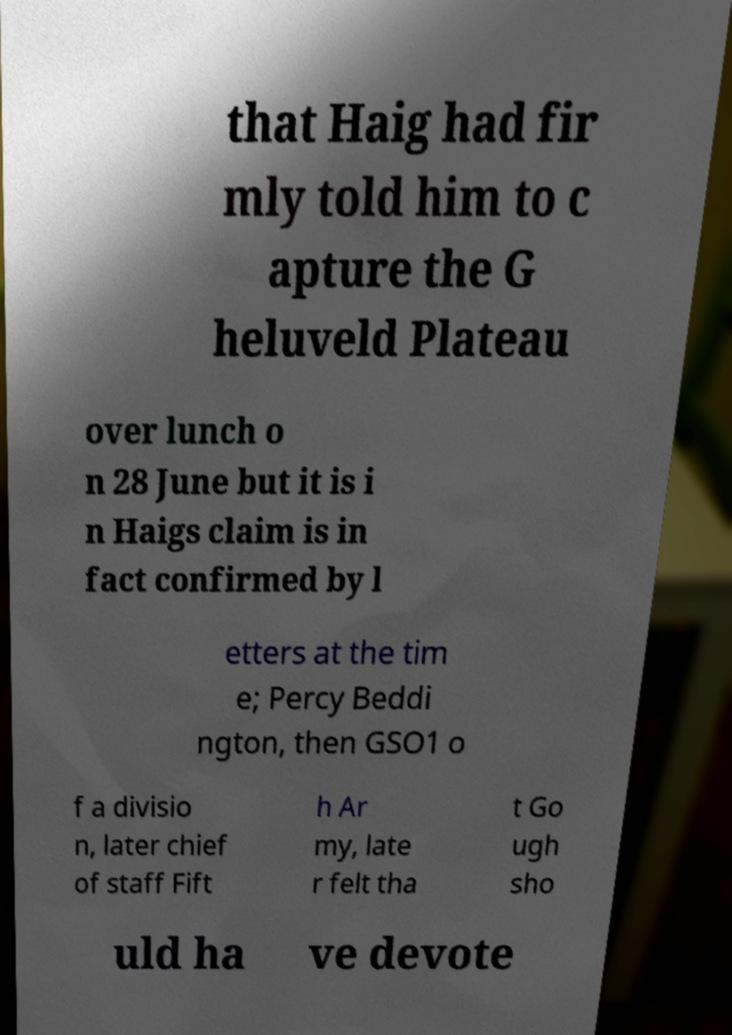Please read and relay the text visible in this image. What does it say? that Haig had fir mly told him to c apture the G heluveld Plateau over lunch o n 28 June but it is i n Haigs claim is in fact confirmed by l etters at the tim e; Percy Beddi ngton, then GSO1 o f a divisio n, later chief of staff Fift h Ar my, late r felt tha t Go ugh sho uld ha ve devote 